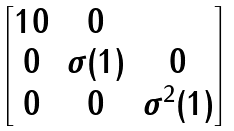Convert formula to latex. <formula><loc_0><loc_0><loc_500><loc_500>\begin{bmatrix} { 1 } 0 & 0 \\ 0 & { \sigma ( 1 ) } & 0 \\ 0 & 0 & { \sigma ^ { 2 } ( 1 ) } \end{bmatrix}</formula> 